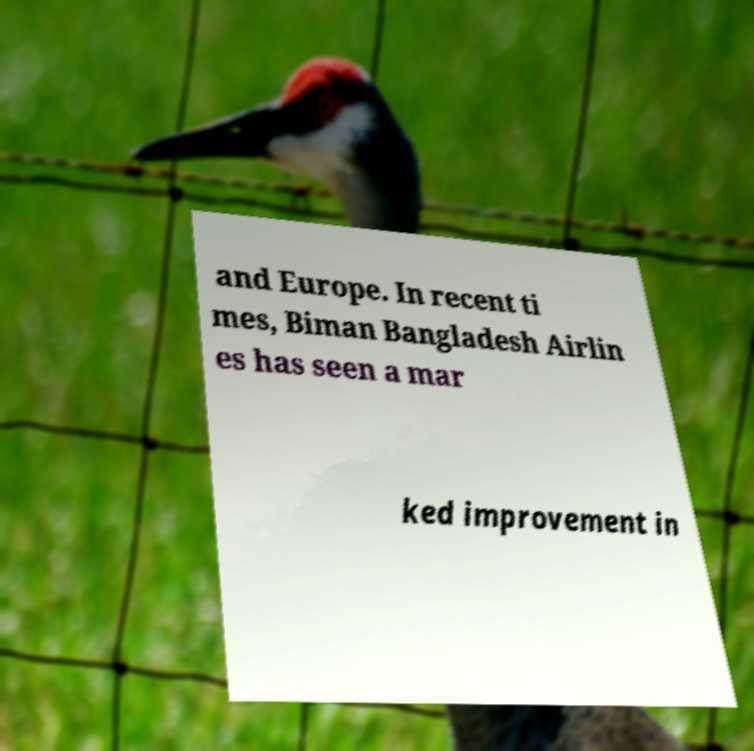Please read and relay the text visible in this image. What does it say? and Europe. In recent ti mes, Biman Bangladesh Airlin es has seen a mar ked improvement in 